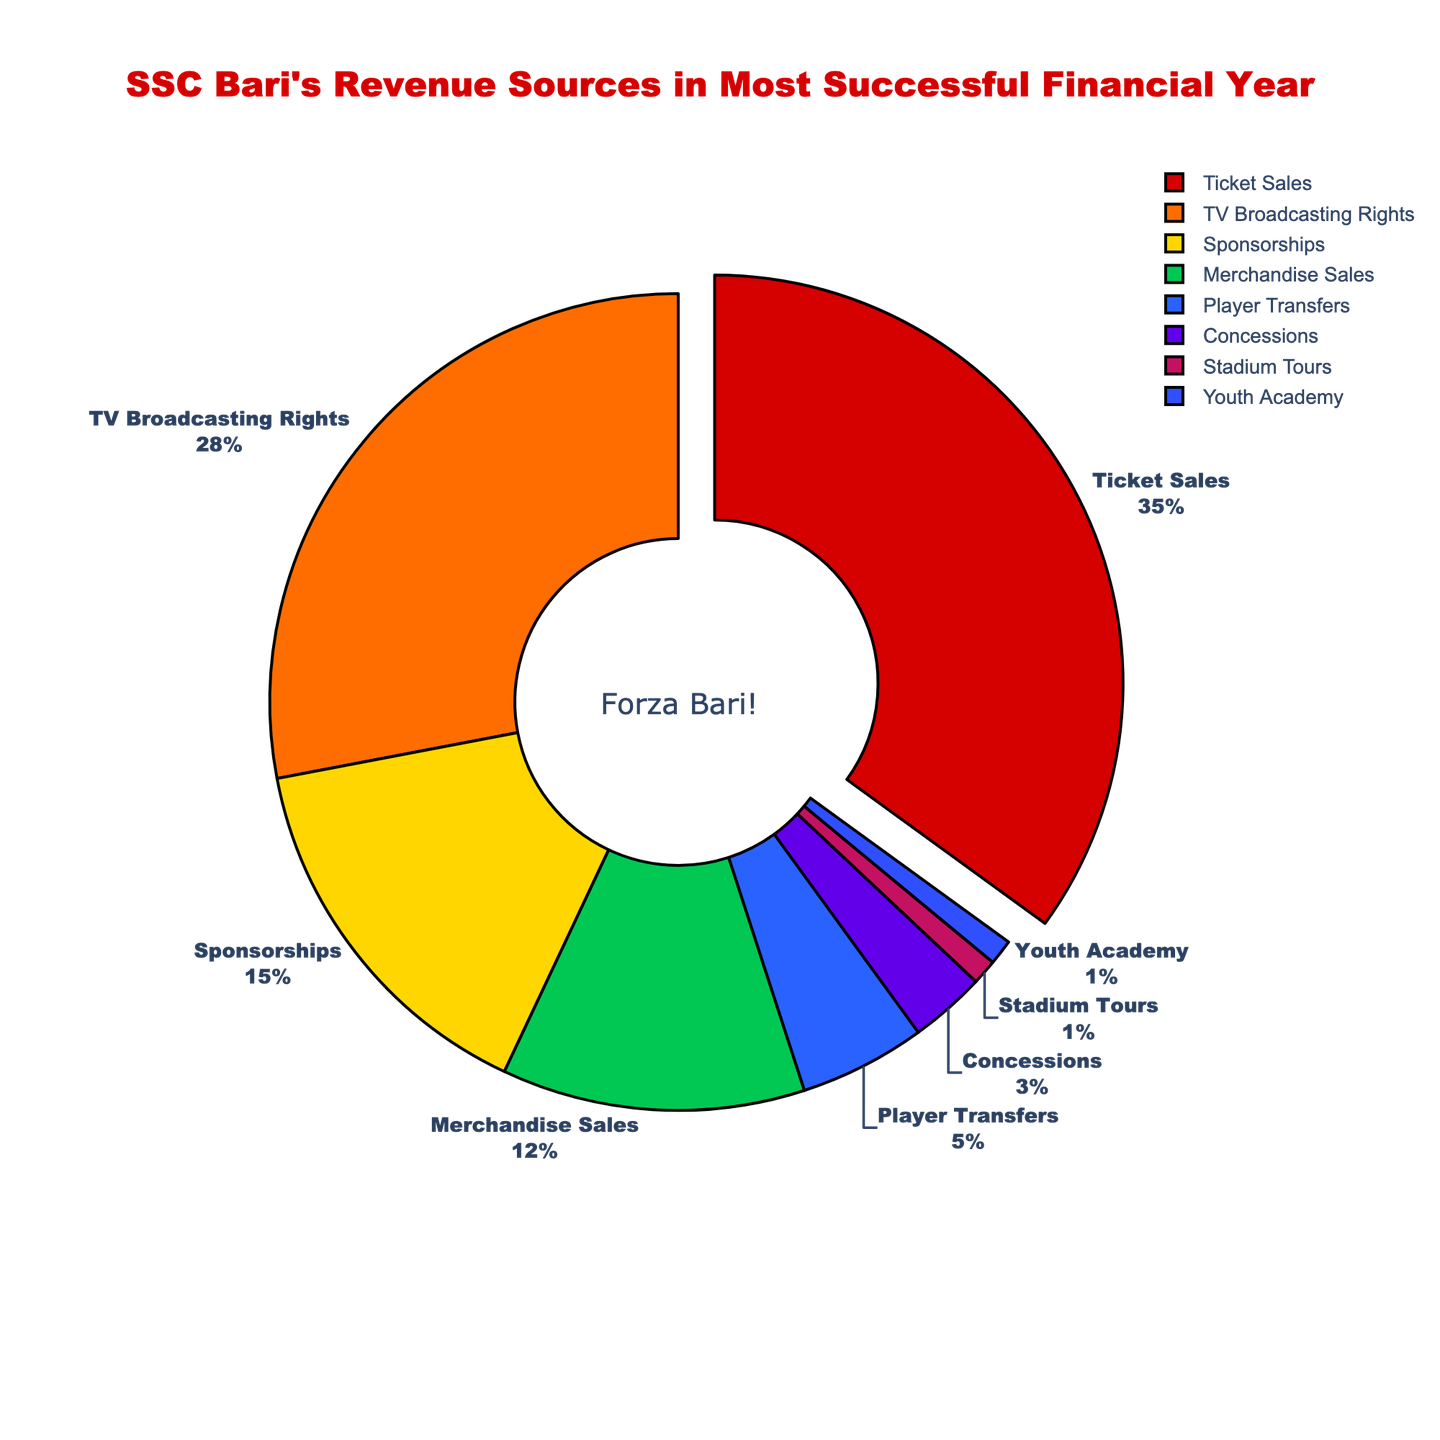What percentage of SSC Bari's revenue comes from Ticket Sales? Ticket Sales are represented on the pie chart with a segment labeled "Ticket Sales". The percentage associated with this segment is labeled as "35%".
Answer: 35% Which revenue source contributes the least to SSC Bari's revenue? The pie chart has segments labeled with various revenue sources. The smallest segments, labeled "Stadium Tours" and "Youth Academy," each contribute 1% of the total revenue.
Answer: Stadium Tours, Youth Academy How much more revenue does TV Broadcasting Rights bring in compared to Sponsorships? The pie chart shows that TV Broadcasting Rights make up 28% of the revenue, while Sponsorships contribute 15%. The difference is calculated as 28% - 15% = 13%.
Answer: 13% What is the total percentage of revenue from Ticket Sales, TV Broadcasting Rights, and Sponsorships combined? To find this total, add the percentages for Ticket Sales (35%), TV Broadcasting Rights (28%), and Sponsorships (15%). The total is 35% + 28% + 15% = 78%.
Answer: 78% Which revenue source has the second-highest contribution to SSC Bari's revenue? By inspecting the labeled segments on the pie chart, the second-largest segment is "TV Broadcasting Rights" with a contribution of 28%.
Answer: TV Broadcasting Rights Is the combined revenue from Player Transfers, Concessions, Stadium Tours, and Youth Academy greater than the revenue from Merchandise Sales? Add the percentages for Player Transfers (5%), Concessions (3%), Stadium Tours (1%), and Youth Academy (1%): 5% + 3% + 1% + 1% = 10%. Compare this to Merchandise Sales which is 12%. Since 10% is less than 12%, the combined revenue is not greater.
Answer: No Among the revenue sources contributing less than 10%, which has the highest percentage? From the pie chart, we see that Player Transfers (5%), Concessions (3%), Stadium Tours (1%), and Youth Academy (1%) contribute less than 10%. Among these, Player Transfers at 5% has the highest percentage.
Answer: Player Transfers What percentage of SSC Bari's revenue comes from sources other than Ticket Sales and TV Broadcasting Rights? First, sum the percentages for Ticket Sales and TV Broadcasting Rights: 35% + 28% = 63%. Subtract this from 100%: 100% - 63% = 37%.
Answer: 37% Does the combination of Sponsorships and Merchandise Sales exceed the revenue from Ticket Sales? Add the percentages for Sponsorships (15%) and Merchandise Sales (12%): 15% + 12% = 27%. Compare this to the Ticket Sales percentage of 35%. Since 27% is less than 35%, the combination does not exceed Ticket Sales.
Answer: No What distinctive visual feature helps identify the segment with the highest revenue contribution? The segment with the highest percentage, Ticket Sales (35%), is visually distinguished by being slightly pulled out from the main pie chart.
Answer: Pulled out segment 